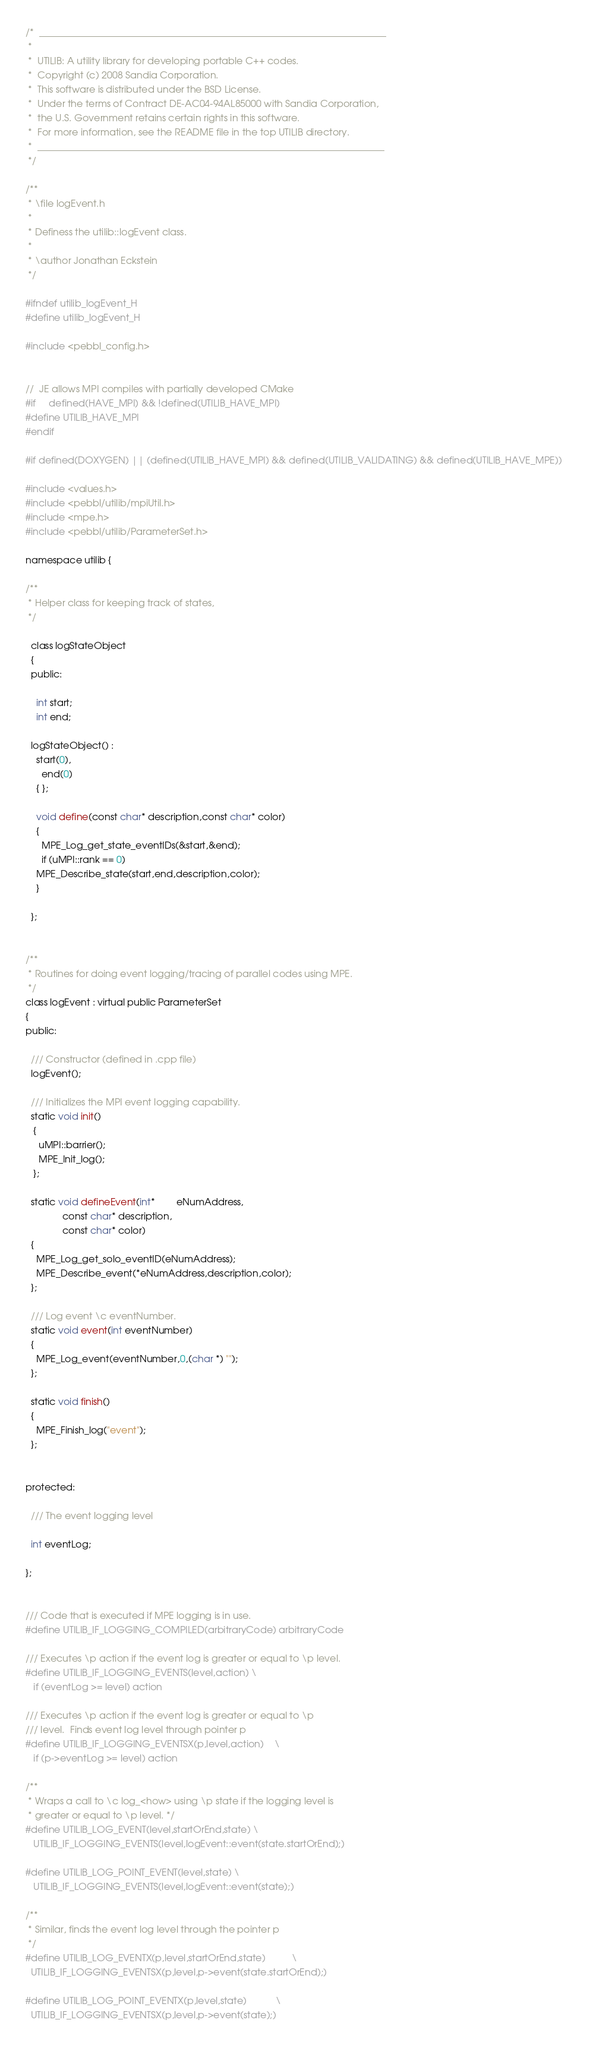Convert code to text. <code><loc_0><loc_0><loc_500><loc_500><_C_>/*  _________________________________________________________________________
 *
 *  UTILIB: A utility library for developing portable C++ codes.
 *  Copyright (c) 2008 Sandia Corporation.
 *  This software is distributed under the BSD License.
 *  Under the terms of Contract DE-AC04-94AL85000 with Sandia Corporation,
 *  the U.S. Government retains certain rights in this software.
 *  For more information, see the README file in the top UTILIB directory.
 *  _________________________________________________________________________
 */

/**
 * \file logEvent.h
 *
 * Definess the utilib::logEvent class.
 *
 * \author Jonathan Eckstein
 */

#ifndef utilib_logEvent_H
#define utilib_logEvent_H

#include <pebbl_config.h>


//  JE allows MPI compiles with partially developed CMake
#if     defined(HAVE_MPI) && !defined(UTILIB_HAVE_MPI)
#define UTILIB_HAVE_MPI
#endif

#if defined(DOXYGEN) || (defined(UTILIB_HAVE_MPI) && defined(UTILIB_VALIDATING) && defined(UTILIB_HAVE_MPE)) 

#include <values.h>
#include <pebbl/utilib/mpiUtil.h>
#include <mpe.h>
#include <pebbl/utilib/ParameterSet.h>

namespace utilib {

/**
 * Helper class for keeping track of states,
 */

  class logStateObject 
  {
  public:

    int start;
    int end;

  logStateObject() :
    start(0),
      end(0)
	{ };

    void define(const char* description,const char* color)
    {
      MPE_Log_get_state_eventIDs(&start,&end);
      if (uMPI::rank == 0)
	MPE_Describe_state(start,end,description,color);
    }

  };


/**
 * Routines for doing event logging/tracing of parallel codes using MPE.
 */
class logEvent : virtual public ParameterSet
{
public:

  /// Constructor (defined in .cpp file)
  logEvent();

  /// Initializes the MPI event logging capability.
  static void init()
   {
     uMPI::barrier();
     MPE_Init_log(); 
   };

  static void defineEvent(int*        eNumAddress,
			  const char* description,
			  const char* color)
  {
    MPE_Log_get_solo_eventID(eNumAddress);
    MPE_Describe_event(*eNumAddress,description,color);
  };

  /// Log event \c eventNumber.
  static void event(int eventNumber) 
  { 
    MPE_Log_event(eventNumber,0,(char *) ""); 
  };

  static void finish()
  { 
    MPE_Finish_log("event");
  };

  
protected:

  /// The event logging level

  int eventLog;

};


/// Code that is executed if MPE logging is in use.
#define UTILIB_IF_LOGGING_COMPILED(arbitraryCode) arbitraryCode

/// Executes \p action if the event log is greater or equal to \p level.
#define UTILIB_IF_LOGGING_EVENTS(level,action) \
   if (eventLog >= level) action

/// Executes \p action if the event log is greater or equal to \p
/// level.  Finds event log level through pointer p
#define UTILIB_IF_LOGGING_EVENTSX(p,level,action)	\
   if (p->eventLog >= level) action

/**
 * Wraps a call to \c log_<how> using \p state if the logging level is 
 * greater or equal to \p level. */
#define UTILIB_LOG_EVENT(level,startOrEnd,state) \
   UTILIB_IF_LOGGING_EVENTS(level,logEvent::event(state.startOrEnd);)

#define UTILIB_LOG_POINT_EVENT(level,state) \
   UTILIB_IF_LOGGING_EVENTS(level,logEvent::event(state);)

/**
 * Similar, finds the event log level through the pointer p
 */
#define UTILIB_LOG_EVENTX(p,level,startOrEnd,state)			\
  UTILIB_IF_LOGGING_EVENTSX(p,level,p->event(state.startOrEnd);)

#define UTILIB_LOG_POINT_EVENTX(p,level,state)			\
  UTILIB_IF_LOGGING_EVENTSX(p,level,p->event(state);)
</code> 